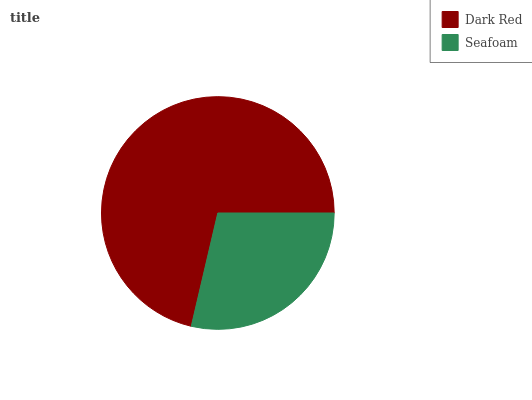Is Seafoam the minimum?
Answer yes or no. Yes. Is Dark Red the maximum?
Answer yes or no. Yes. Is Seafoam the maximum?
Answer yes or no. No. Is Dark Red greater than Seafoam?
Answer yes or no. Yes. Is Seafoam less than Dark Red?
Answer yes or no. Yes. Is Seafoam greater than Dark Red?
Answer yes or no. No. Is Dark Red less than Seafoam?
Answer yes or no. No. Is Dark Red the high median?
Answer yes or no. Yes. Is Seafoam the low median?
Answer yes or no. Yes. Is Seafoam the high median?
Answer yes or no. No. Is Dark Red the low median?
Answer yes or no. No. 